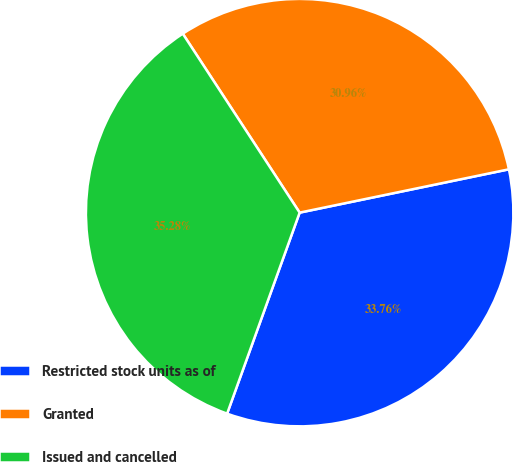<chart> <loc_0><loc_0><loc_500><loc_500><pie_chart><fcel>Restricted stock units as of<fcel>Granted<fcel>Issued and cancelled<nl><fcel>33.76%<fcel>30.96%<fcel>35.28%<nl></chart> 